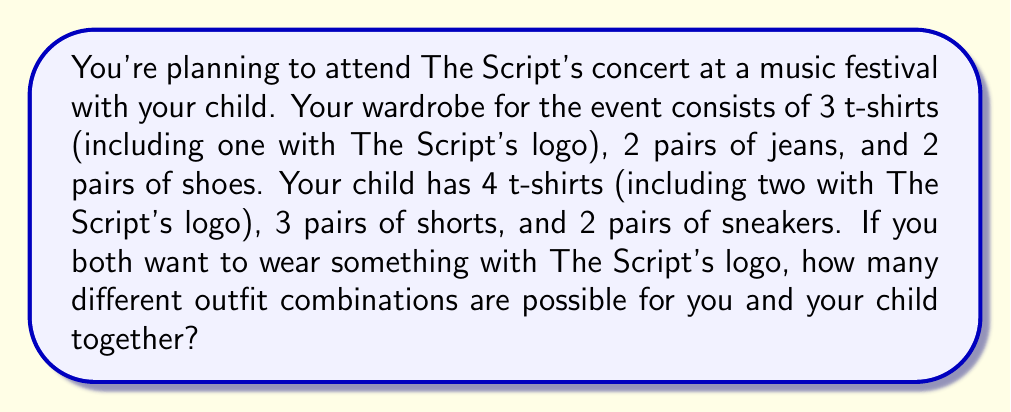Can you solve this math problem? Let's break this down step-by-step:

1) For you (the parent):
   - T-shirts: You must wear The Script logo shirt, so 1 choice
   - Jeans: 2 choices
   - Shoes: 2 choices

2) For your child:
   - T-shirts: Must choose from The Script logo shirts, so 2 choices
   - Shorts: 3 choices
   - Sneakers: 2 choices

3) For your outfit:
   Number of combinations = $1 \times 2 \times 2 = 4$

4) For your child's outfit:
   Number of combinations = $2 \times 3 \times 2 = 12$

5) To find the total number of possible combinations for both of you together, we multiply your combinations by your child's combinations:

   Total combinations = Your combinations $\times$ Child's combinations
                      = $4 \times 12 = 48$

Therefore, there are 48 different outfit combinations possible for you and your child together.
Answer: $48$ 